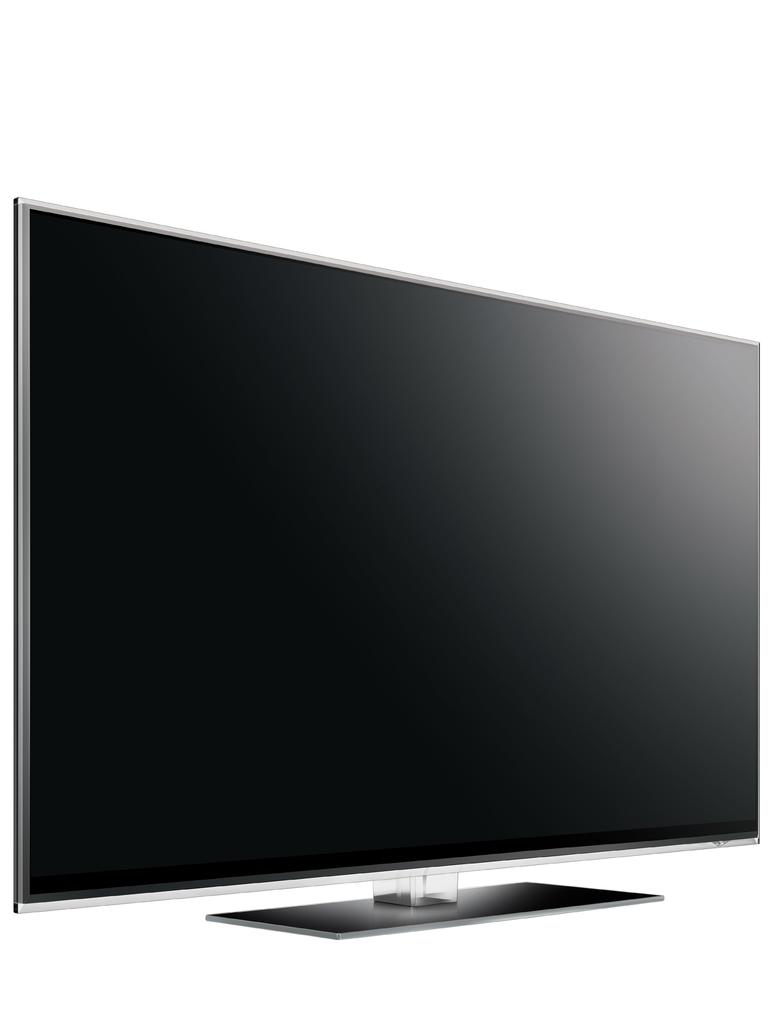What is the main object in the image? There is a television in the image. What rule is being discussed during the meeting in the image? There is no meeting or discussion of rules present in the image; it only features a television. 